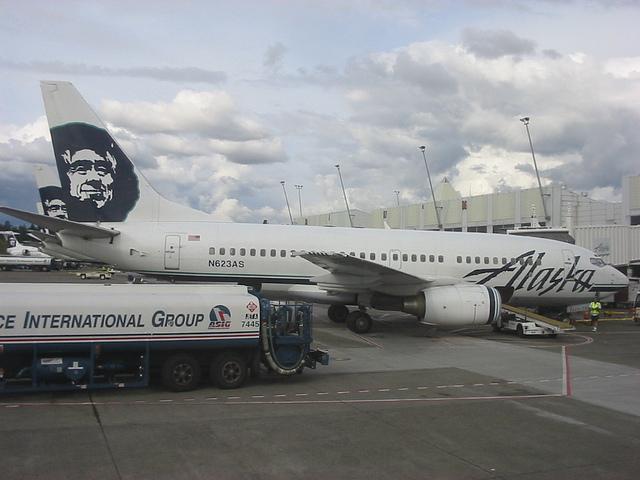Is the plane in motion?
Be succinct. No. Are all the planes from the same company?
Answer briefly. Yes. Where is the plane?
Quick response, please. Airport. How many people are in this image?
Keep it brief. 1. 